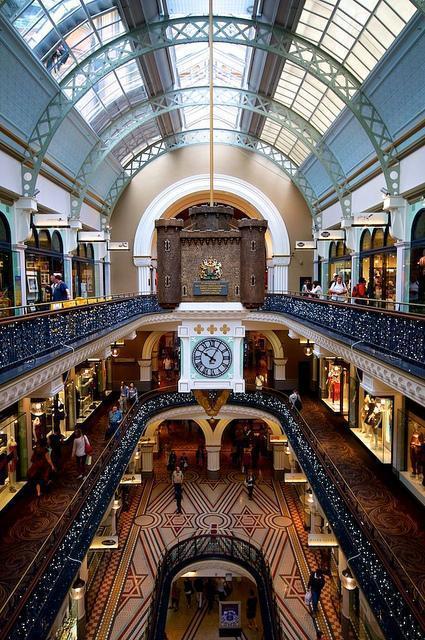How many floors are there in this building?
Give a very brief answer. 4. How many benches are in the picture?
Give a very brief answer. 0. 